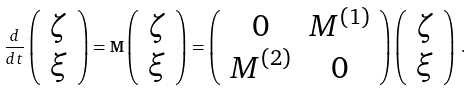Convert formula to latex. <formula><loc_0><loc_0><loc_500><loc_500>\frac { d } { d t } \left ( \begin{array} { c } \zeta \\ \xi \\ \end{array} \right ) = { \mathbf M } \left ( \begin{array} { c } \zeta \\ \xi \\ \end{array} \right ) = \left ( \begin{array} { c c } 0 & M ^ { ( 1 ) } \\ M ^ { ( 2 ) } & 0 \\ \end{array} \right ) \left ( \begin{array} { c } \zeta \\ \xi \\ \end{array} \right ) \, .</formula> 